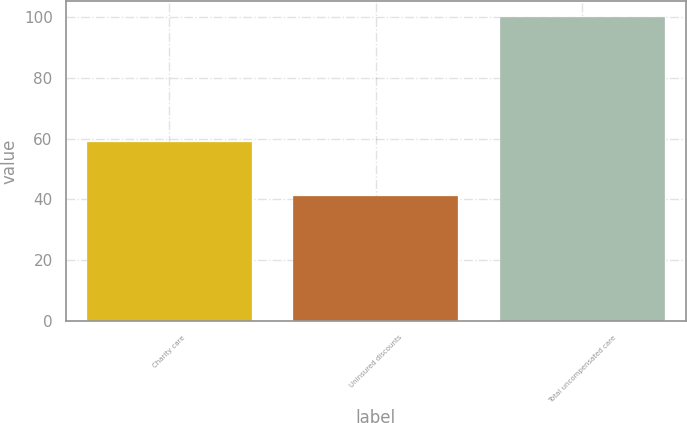Convert chart to OTSL. <chart><loc_0><loc_0><loc_500><loc_500><bar_chart><fcel>Charity care<fcel>Uninsured discounts<fcel>Total uncompensated care<nl><fcel>59<fcel>41<fcel>100<nl></chart> 